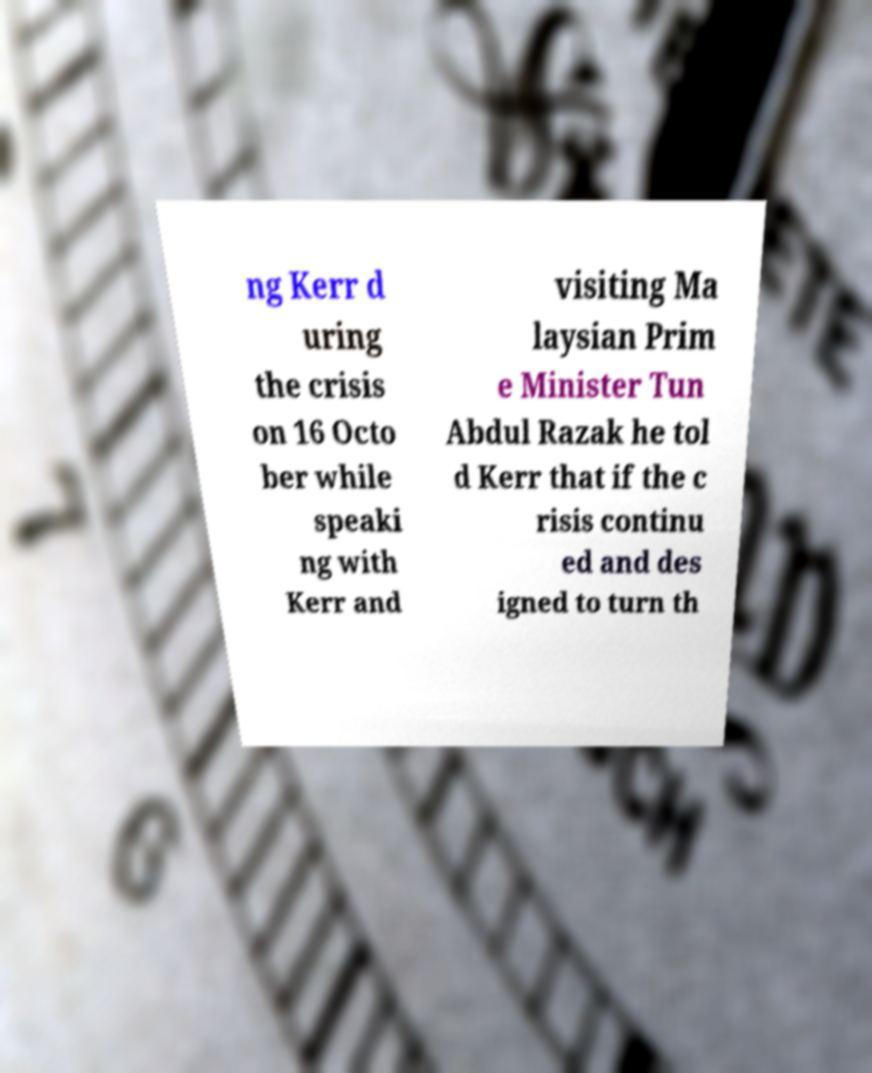Can you accurately transcribe the text from the provided image for me? ng Kerr d uring the crisis on 16 Octo ber while speaki ng with Kerr and visiting Ma laysian Prim e Minister Tun Abdul Razak he tol d Kerr that if the c risis continu ed and des igned to turn th 